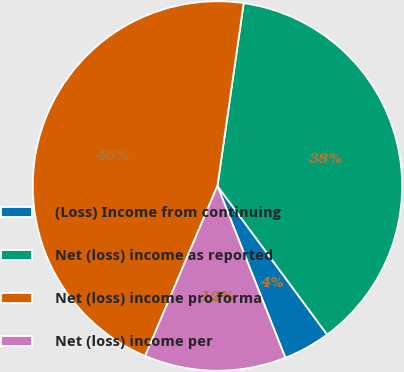<chart> <loc_0><loc_0><loc_500><loc_500><pie_chart><fcel>(Loss) Income from continuing<fcel>Net (loss) income as reported<fcel>Net (loss) income pro forma<fcel>Net (loss) income per<nl><fcel>4.13%<fcel>37.61%<fcel>45.87%<fcel>12.39%<nl></chart> 